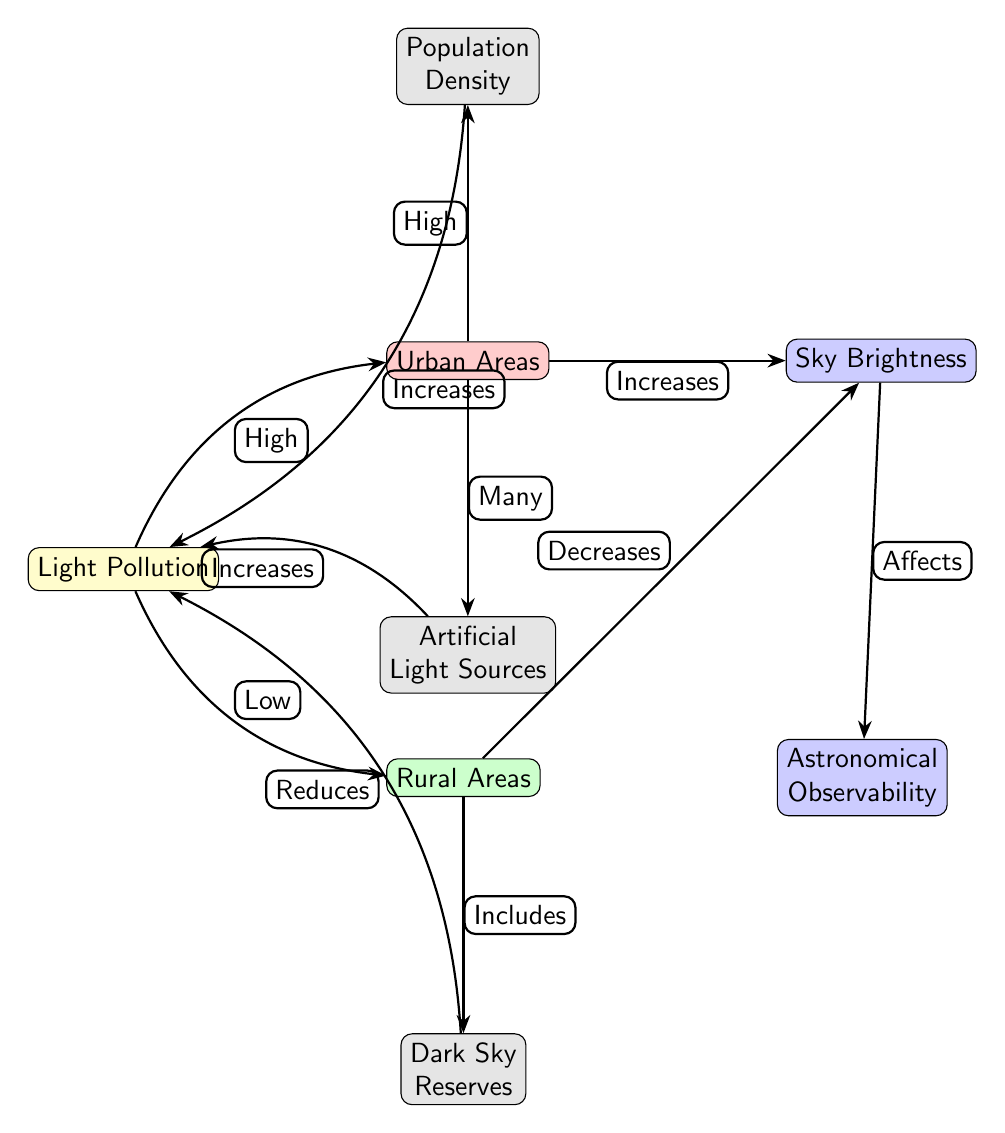What is the relationship between light pollution and urban areas? The diagram shows that light pollution is categorized as "High" in urban areas, indicating that there is a direct relationship where urban settings contribute to greater levels of light pollution.
Answer: High How does light pollution affect sky brightness in urban areas? The arrow from light pollution to sky brightness labeled "Increases" indicates that as light pollution rises in urban areas, the sky brightness also increases.
Answer: Increases What node is connected to rural areas that influences light pollution? The diagram indicates that rural areas include "Dark Sky Reserves," which are intended to preserve lower light pollution. Thus, this is the associated node influencing light pollution.
Answer: Dark Sky Reserves How does population density influence light pollution in urban areas? The flow from urban areas to population density shows "High," suggesting that a higher population density is linked to elevated artificial light sources, which in turn increases light pollution.
Answer: High What is the effect of artificial light sources in urban areas on light pollution? There is a connection showing that urban areas, having many artificial light sources, lead to an increase in light pollution. This is specified by the edge labeled "Increases."
Answer: Increases Which area is more directly affected by light pollution, urban or rural? In the diagram, the label "High" indicates that urban areas are more severely impacted by light pollution compared to rural areas, which shows a "Low" level of light pollution.
Answer: Urban What effect does rural area's dark sky reserves have on light pollution? The diagram states that dark sky reserves reduce light pollution, indicated by the edge labeled "Reduces" connecting dark sky reserves to light pollution.
Answer: Reduces What is the brightness level of the sky in rural areas according to the diagram? The diagram indicates that light pollution in rural areas is characterized as "Low," which affects the sky brightness, suggesting a decrease in sky brightness compared to urban locations.
Answer: Decreases 